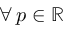Convert formula to latex. <formula><loc_0><loc_0><loc_500><loc_500>\forall \, p \in \mathbb { R }</formula> 